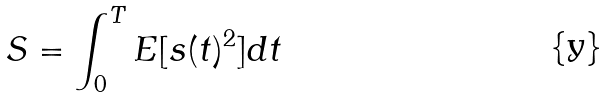<formula> <loc_0><loc_0><loc_500><loc_500>S = \int _ { 0 } ^ { T } E [ s ( t ) ^ { 2 } ] d t</formula> 